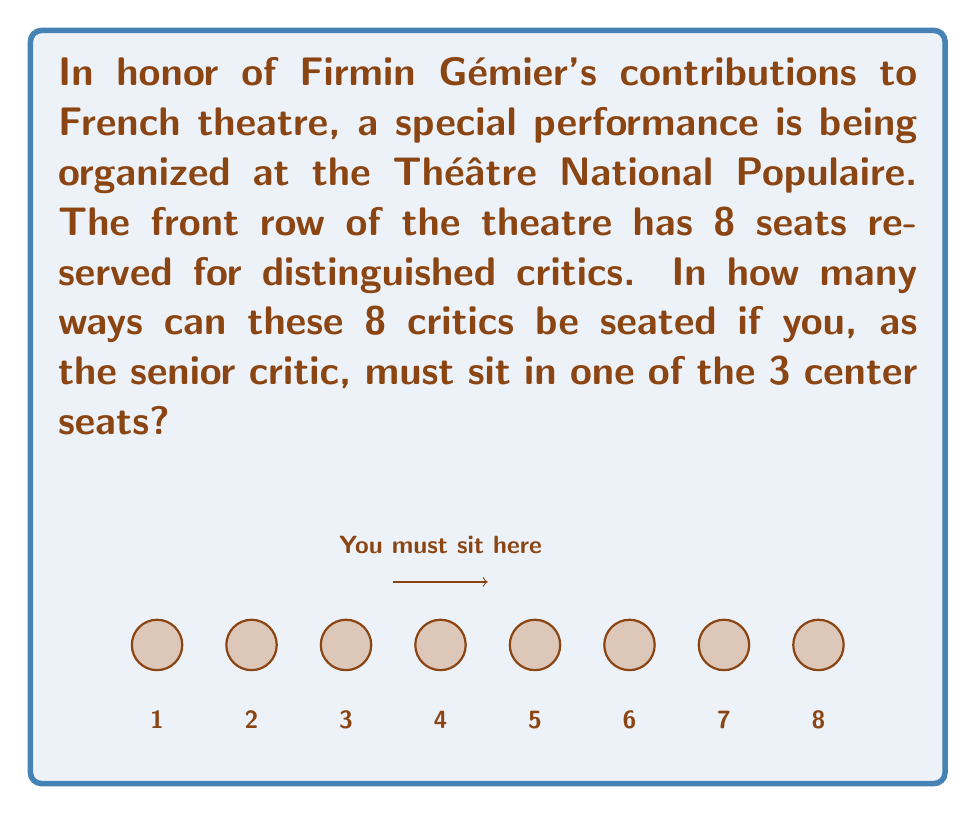Give your solution to this math problem. Let's approach this step-by-step:

1) First, we need to consider that you, as the senior critic, must sit in one of the 3 center seats (seats 3, 4, or 5).

2) We can break this down into three cases:

   Case 1: You sit in seat 3
   Case 2: You sit in seat 4
   Case 3: You sit in seat 5

3) For each case, we need to calculate the number of ways to arrange the remaining 7 critics in the other 7 seats.

4) The number of ways to arrange 7 people in 7 seats is simply 7!, which is:

   $7! = 7 \times 6 \times 5 \times 4 \times 3 \times 2 \times 1 = 5040$

5) Since this is true for each of the three cases, and the cases are mutually exclusive, we multiply the result by 3:

   $3 \times 7! = 3 \times 5040 = 15120$

6) Therefore, the total number of possible seating arrangements is 15120.

This calculation can be expressed mathematically as:

$$3 \times 7! = 3 \times (7 \times 6 \times 5 \times 4 \times 3 \times 2 \times 1) = 15120$$
Answer: 15120 